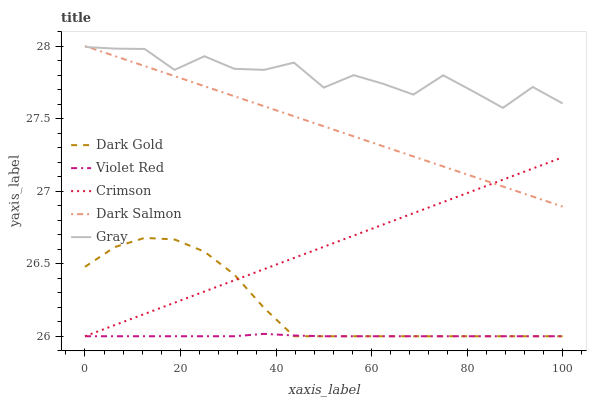Does Violet Red have the minimum area under the curve?
Answer yes or no. Yes. Does Gray have the maximum area under the curve?
Answer yes or no. Yes. Does Gray have the minimum area under the curve?
Answer yes or no. No. Does Violet Red have the maximum area under the curve?
Answer yes or no. No. Is Dark Salmon the smoothest?
Answer yes or no. Yes. Is Gray the roughest?
Answer yes or no. Yes. Is Violet Red the smoothest?
Answer yes or no. No. Is Violet Red the roughest?
Answer yes or no. No. Does Crimson have the lowest value?
Answer yes or no. Yes. Does Gray have the lowest value?
Answer yes or no. No. Does Dark Salmon have the highest value?
Answer yes or no. Yes. Does Gray have the highest value?
Answer yes or no. No. Is Violet Red less than Gray?
Answer yes or no. Yes. Is Gray greater than Crimson?
Answer yes or no. Yes. Does Crimson intersect Dark Gold?
Answer yes or no. Yes. Is Crimson less than Dark Gold?
Answer yes or no. No. Is Crimson greater than Dark Gold?
Answer yes or no. No. Does Violet Red intersect Gray?
Answer yes or no. No. 